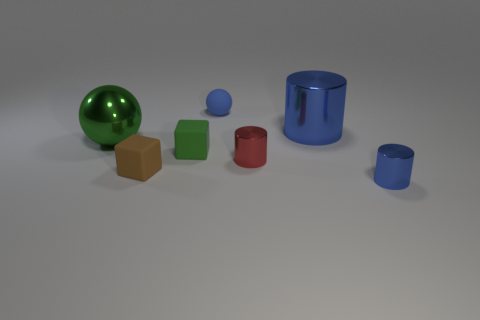What shape is the red thing that is the same size as the green cube?
Provide a succinct answer. Cylinder. There is a small green block; are there any big blue objects in front of it?
Provide a short and direct response. No. Do the ball that is in front of the blue matte thing and the small thing behind the large shiny ball have the same material?
Your answer should be compact. No. What number of green shiny things are the same size as the red metal cylinder?
Your answer should be very brief. 0. There is a shiny thing that is the same color as the large cylinder; what is its shape?
Keep it short and to the point. Cylinder. There is a big thing on the right side of the green metallic thing; what is it made of?
Your answer should be compact. Metal. What number of tiny red objects have the same shape as the green metal object?
Your answer should be very brief. 0. There is a tiny thing that is the same material as the small red cylinder; what shape is it?
Keep it short and to the point. Cylinder. There is a blue shiny thing in front of the large thing to the left of the big metal object that is behind the large shiny sphere; what shape is it?
Offer a terse response. Cylinder. Is the number of big things greater than the number of yellow shiny things?
Give a very brief answer. Yes. 